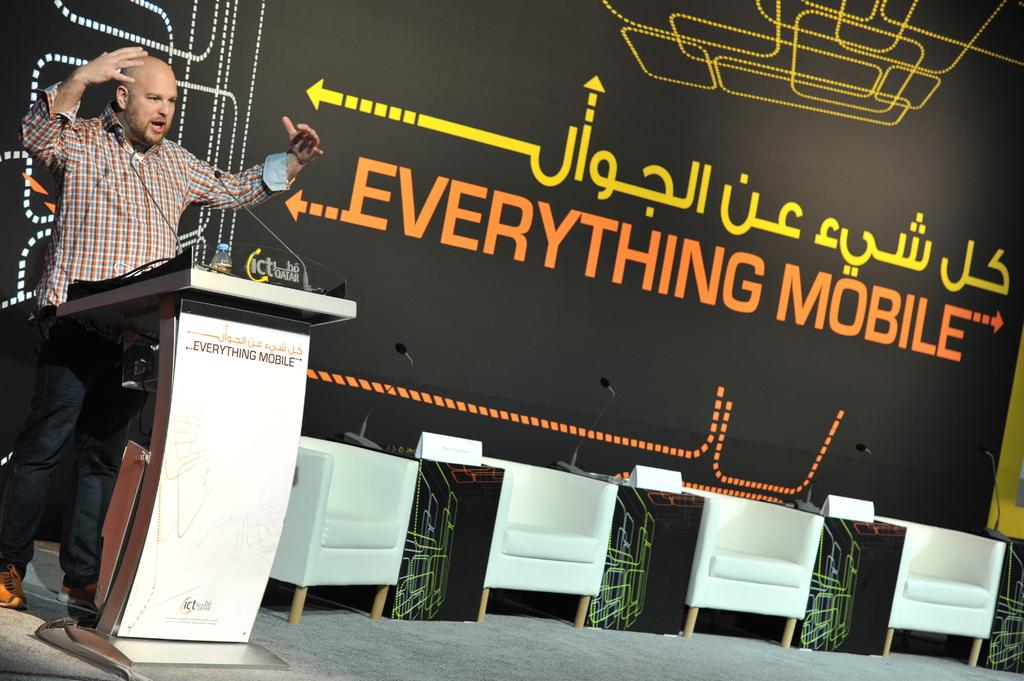Who is the main subject in the image? There is a man in the image. What is the man doing in the image? The man is talking with a microphone in front of him. Are there any other people present in the image? There are empty chairs beside the man, suggesting that other people might be present or expected. What can be seen in the background of the image? There is a poster in the background of the image, named "Everything Mobile." What type of button can be seen on the man's shirt in the image? There is no button visible on the man's shirt in the image. How much profit is the man making from his speech in the image? The image does not provide any information about the man's profit or financial gain from his speech. 